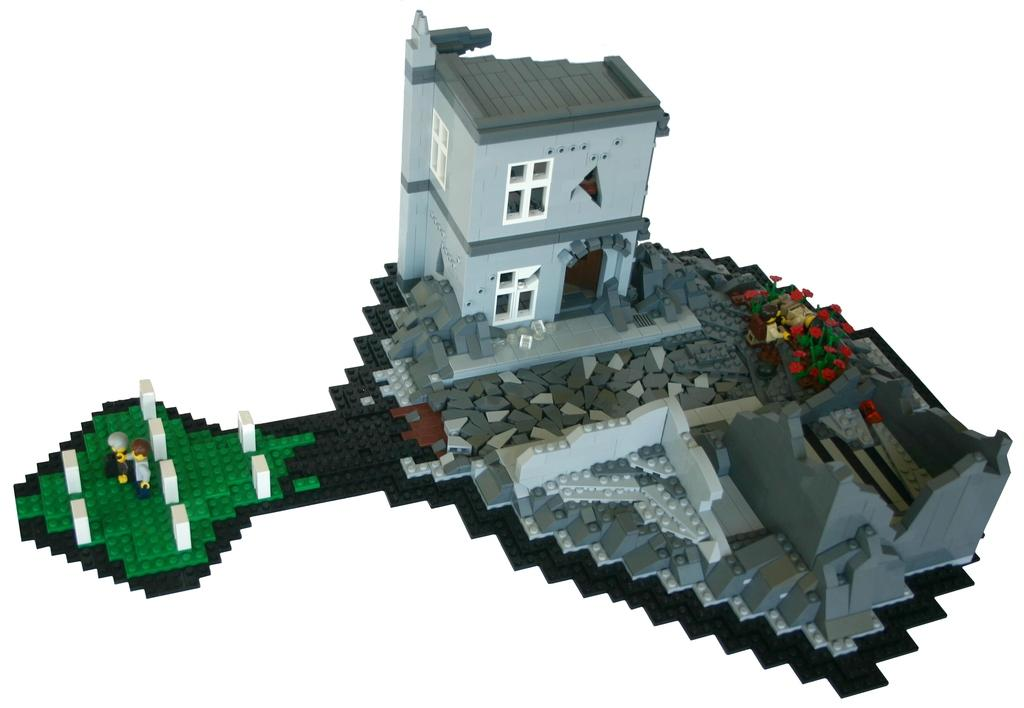What is the main subject of the image? There is a depiction of a building in the center of the image. Can you describe the building in the image? Unfortunately, the provided facts do not give any details about the building's appearance or characteristics. Are there any other elements in the image besides the building? The given facts do not mention any other elements in the image. How many sheep are in the flock depicted in the image? There is no flock of sheep present in the image; it only features a depiction of a building. 